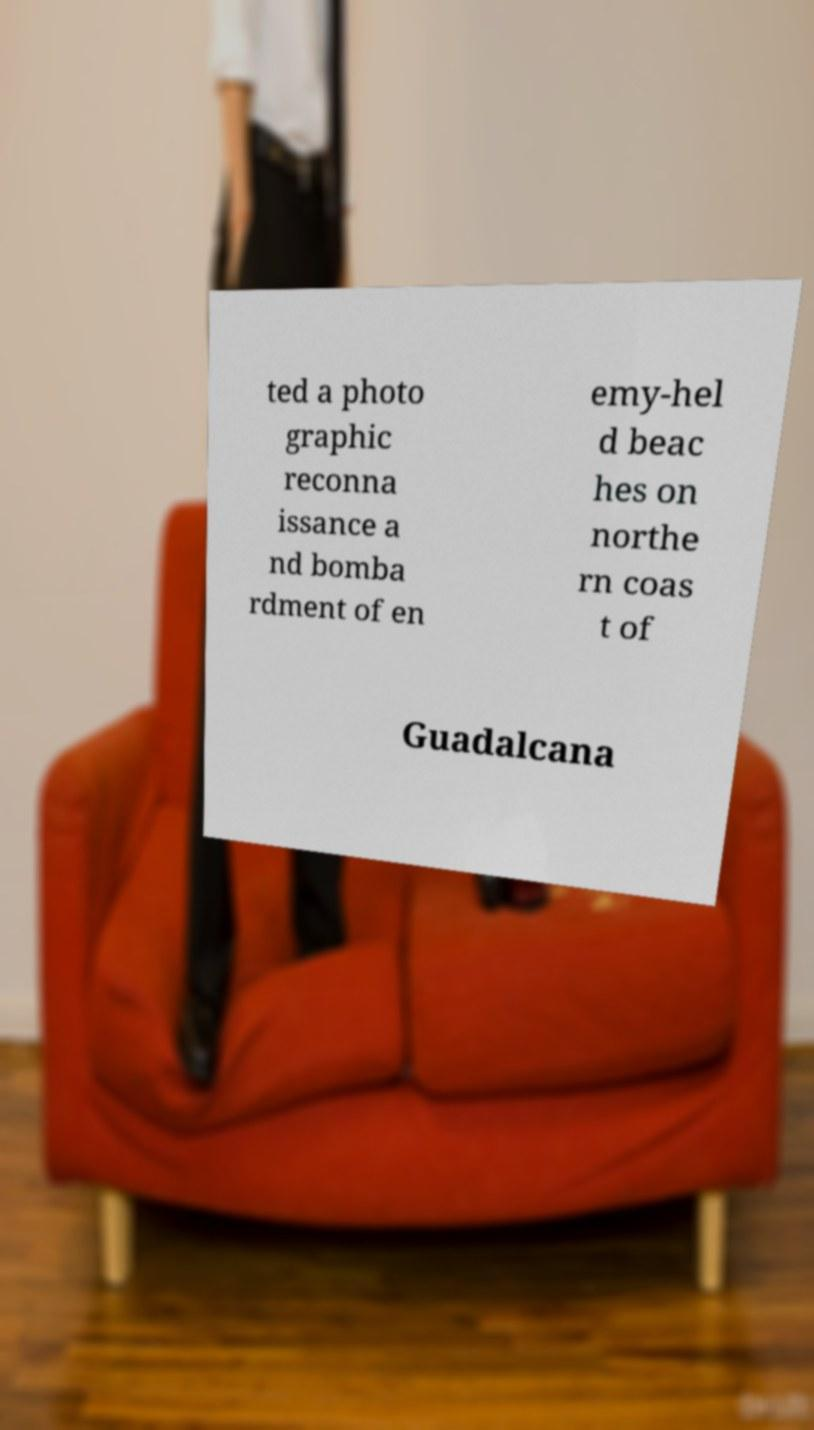Could you extract and type out the text from this image? ted a photo graphic reconna issance a nd bomba rdment of en emy-hel d beac hes on northe rn coas t of Guadalcana 